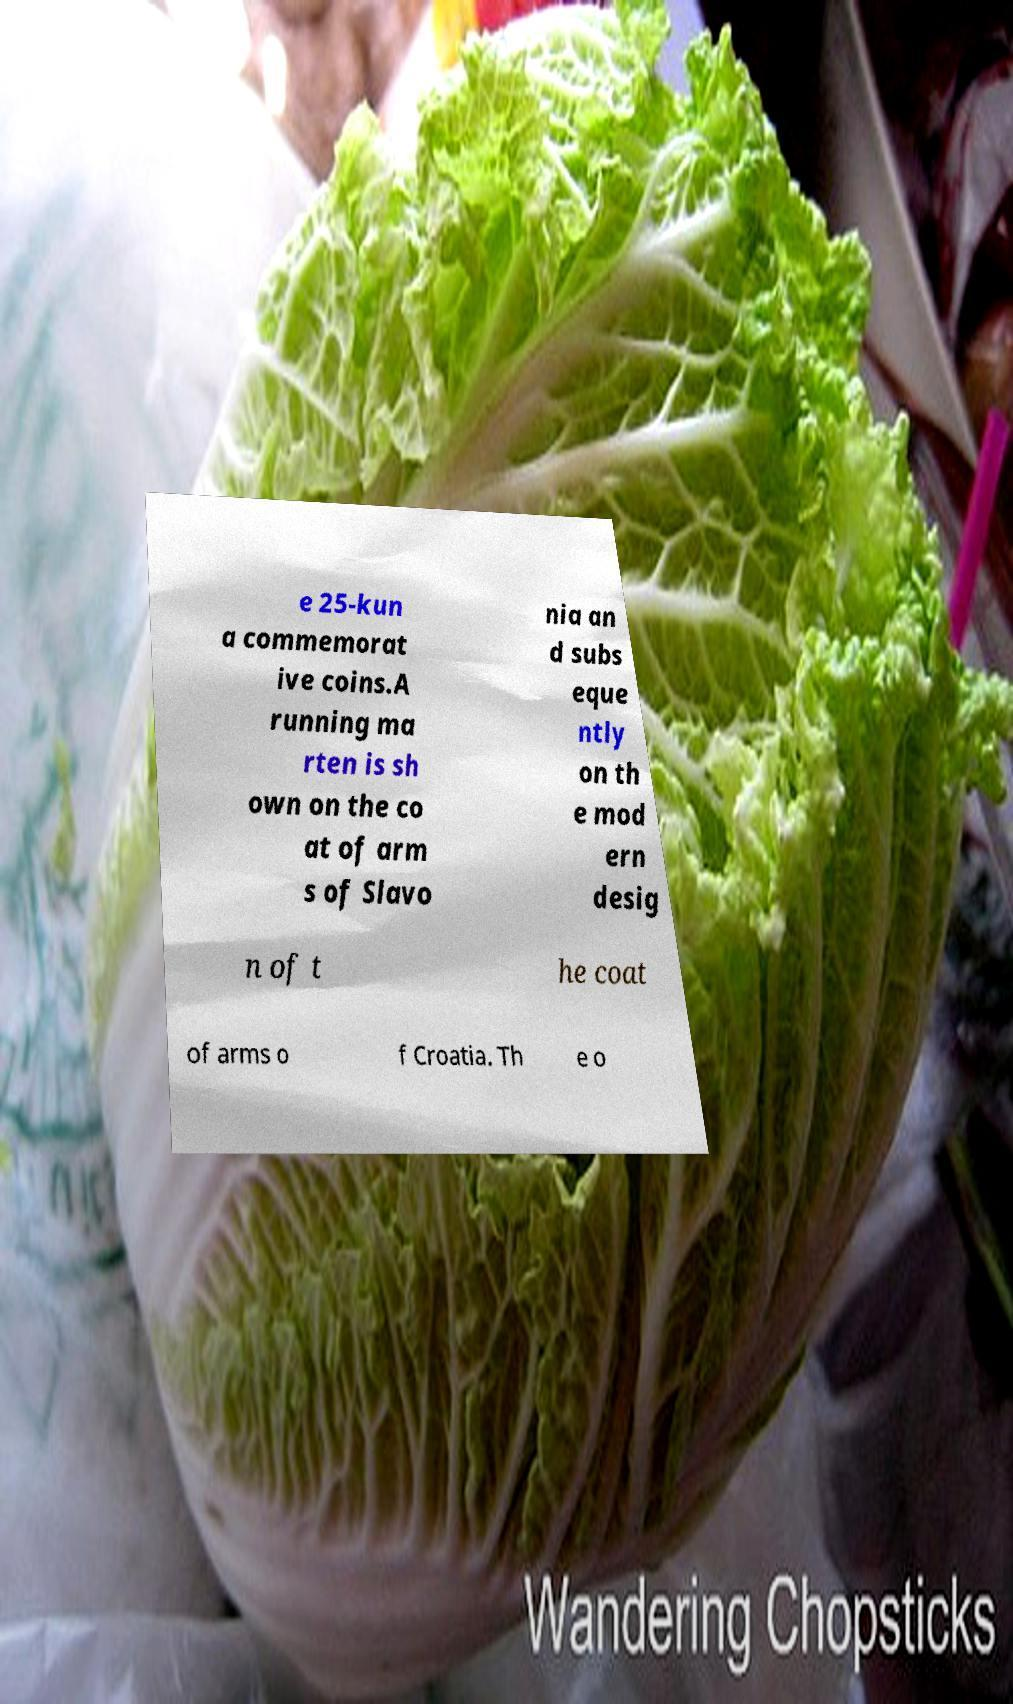There's text embedded in this image that I need extracted. Can you transcribe it verbatim? e 25-kun a commemorat ive coins.A running ma rten is sh own on the co at of arm s of Slavo nia an d subs eque ntly on th e mod ern desig n of t he coat of arms o f Croatia. Th e o 